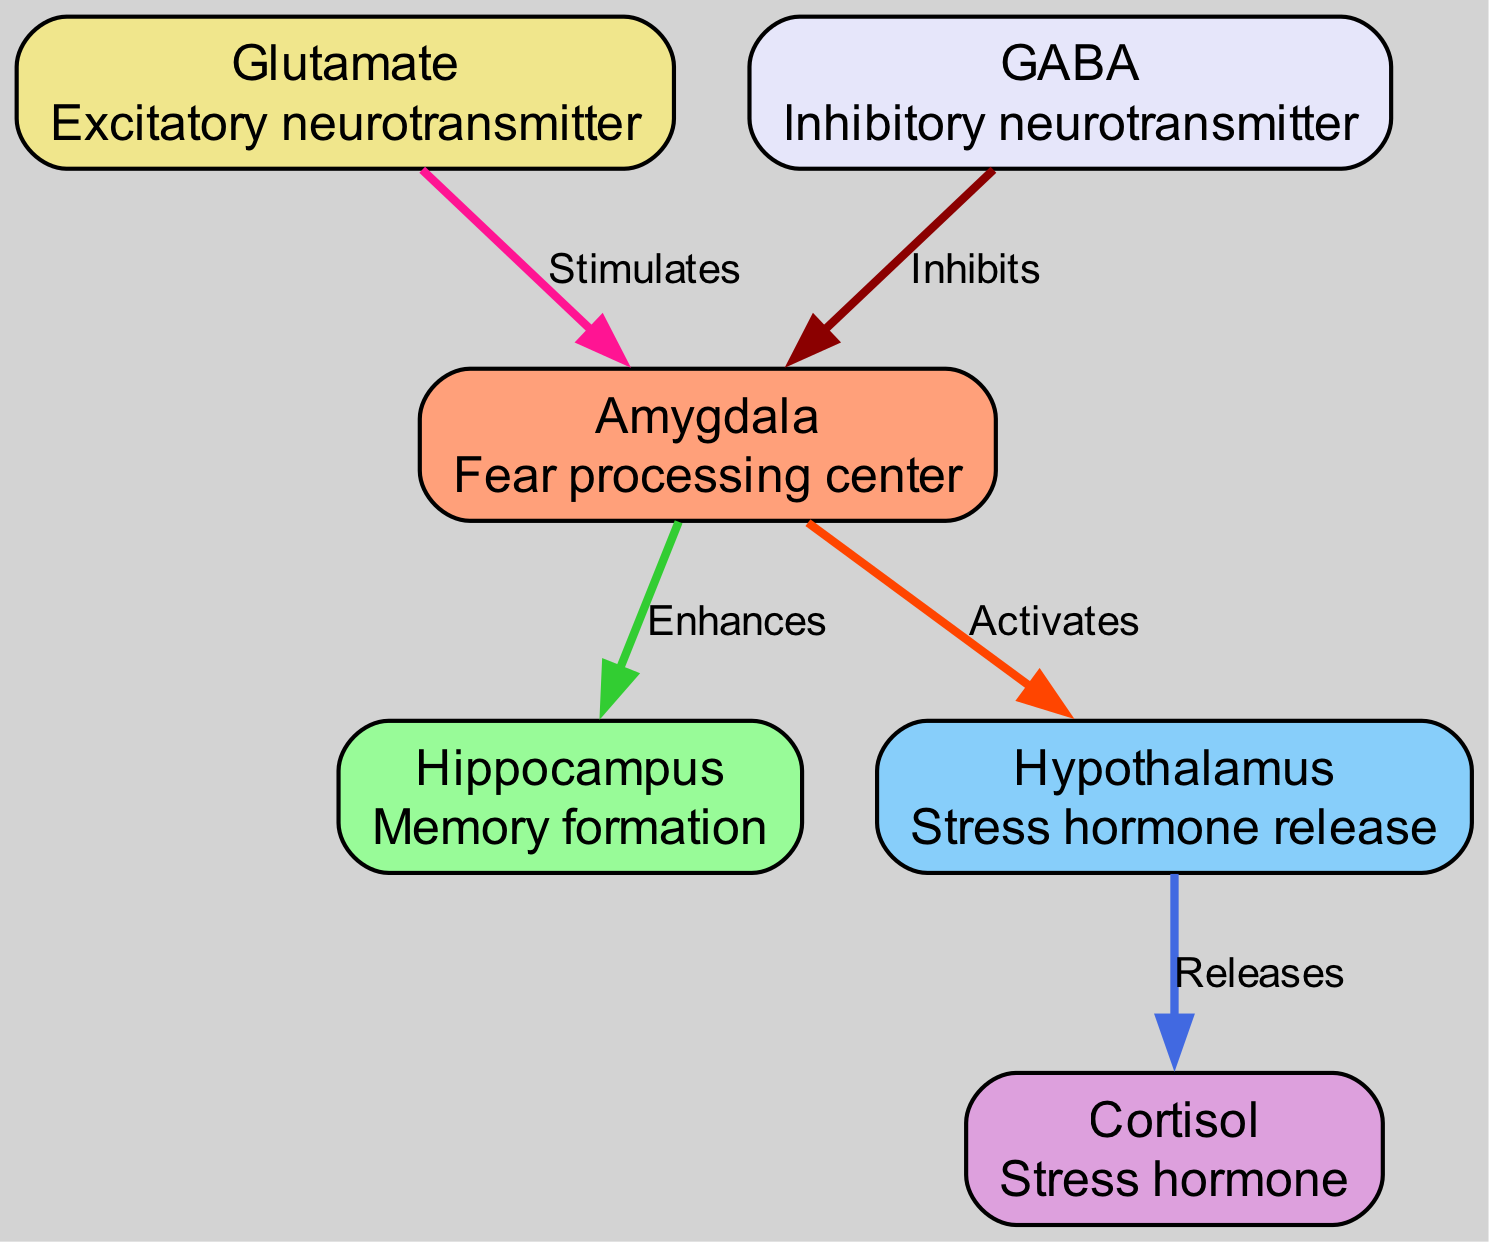What is the role of the amygdala? The amygdala is labeled as the "Fear processing center" in the diagram. This description directly identifies its primary function.
Answer: Fear processing center How many nodes are there in the diagram? By counting the individual elements under "nodes," we find there are six distinct nodes representing various components of the fear response pathway.
Answer: 6 What neurotransmitter is stimulated by glutamate? The diagram indicates that glutamate "Stimulates" the "amygdala," meaning glutamate is the neurotransmitter that has this stimulating effect.
Answer: Amygdala What is released by the hypothalamus? The hypothalamus in the diagram is linked to "cortisol" by the label "Releases," indicating that the hypothalamus releases cortisol as part of the fear response pathway.
Answer: Cortisol Which node enhances the hippocampus? The diagram shows an arrow from the "amygdala" labeled "Enhances," indicating that the amygdala has an enhancing influence specifically on the hippocampus.
Answer: Amygdala What effect does GABA have on the amygdala? GABA is shown in the diagram with an edge labeled "Inhibits," which describes its action having an inhibitory effect on the amygdala.
Answer: Inhibits How many edges are depicted in the diagram? By counting the connections outlined under "edges," there are five distinct relationships depicted connecting the various nodes within the fear response pathway diagram.
Answer: 5 Which neurotransmitter is referred to as an excitatory neurotransmitter? The node labeled "Glutamate" has the description "Excitatory neurotransmitter" associated with it, identifying glutamate in that specific role.
Answer: Glutamate What is the connection between the amygdala and the hypothalamus? The diagram illustrates that the amygdala "Activates" the hypothalamus, denoting a directional relationship where the amygdala triggers the hypothalamus to respond.
Answer: Activates 